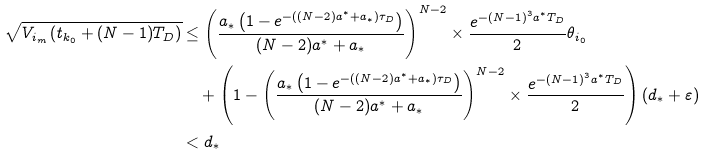Convert formula to latex. <formula><loc_0><loc_0><loc_500><loc_500>\sqrt { V _ { i _ { m } } \left ( t _ { k _ { 0 } } + ( N - 1 ) T _ { D } \right ) } & \leq \left ( \frac { a _ { \ast } \left ( 1 - e ^ { - ( ( N - 2 ) a ^ { \ast } + a _ { \ast } ) \tau _ { D } } \right ) } { ( N - 2 ) a ^ { \ast } + a _ { \ast } } \right ) ^ { N - 2 } \times \frac { e ^ { - ( N - 1 ) ^ { 3 } a ^ { \ast } T _ { D } } } { 2 } \theta _ { i _ { 0 } } \\ & \quad + \left ( 1 - \left ( \frac { a _ { \ast } \left ( 1 - e ^ { - ( ( N - 2 ) a ^ { \ast } + a _ { \ast } ) \tau _ { D } } \right ) } { ( N - 2 ) a ^ { \ast } + a _ { \ast } } \right ) ^ { N - 2 } \times \frac { e ^ { - ( N - 1 ) ^ { 3 } a ^ { \ast } T _ { D } } } { 2 } \right ) ( d _ { \ast } + \varepsilon ) \\ & < d _ { \ast }</formula> 